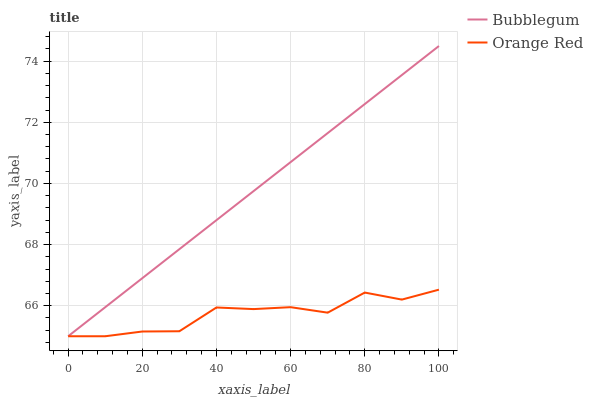Does Orange Red have the minimum area under the curve?
Answer yes or no. Yes. Does Bubblegum have the maximum area under the curve?
Answer yes or no. Yes. Does Bubblegum have the minimum area under the curve?
Answer yes or no. No. Is Bubblegum the smoothest?
Answer yes or no. Yes. Is Orange Red the roughest?
Answer yes or no. Yes. Is Bubblegum the roughest?
Answer yes or no. No. Does Orange Red have the lowest value?
Answer yes or no. Yes. Does Bubblegum have the highest value?
Answer yes or no. Yes. Does Bubblegum intersect Orange Red?
Answer yes or no. Yes. Is Bubblegum less than Orange Red?
Answer yes or no. No. Is Bubblegum greater than Orange Red?
Answer yes or no. No. 